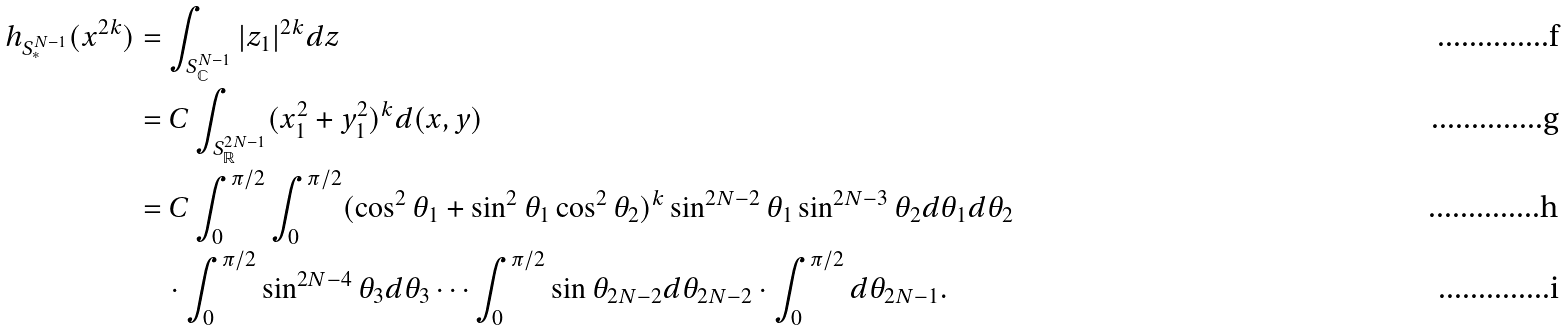Convert formula to latex. <formula><loc_0><loc_0><loc_500><loc_500>h _ { S ^ { N - 1 } _ { * } } ( x ^ { 2 k } ) & = \int _ { S _ { \mathbb { C } } ^ { N - 1 } } | z _ { 1 } | ^ { 2 k } d z \\ & = C \int _ { S _ { \mathbb { R } } ^ { 2 N - 1 } } ( x _ { 1 } ^ { 2 } + y _ { 1 } ^ { 2 } ) ^ { k } d ( x , y ) \\ & = C \int _ { 0 } ^ { \pi / 2 } \int _ { 0 } ^ { \pi / 2 } ( \cos ^ { 2 } \theta _ { 1 } + \sin ^ { 2 } \theta _ { 1 } \cos ^ { 2 } \theta _ { 2 } ) ^ { k } \sin ^ { 2 N - 2 } \theta _ { 1 } \sin ^ { 2 N - 3 } \theta _ { 2 } d \theta _ { 1 } d \theta _ { 2 } \\ & \quad \cdot \int _ { 0 } ^ { \pi / 2 } \sin ^ { 2 N - 4 } \theta _ { 3 } d \theta _ { 3 } \cdots \int _ { 0 } ^ { \pi / 2 } \sin \theta _ { 2 N - 2 } d \theta _ { 2 N - 2 } \cdot \int _ { 0 } ^ { \pi / 2 } d \theta _ { 2 N - 1 } .</formula> 